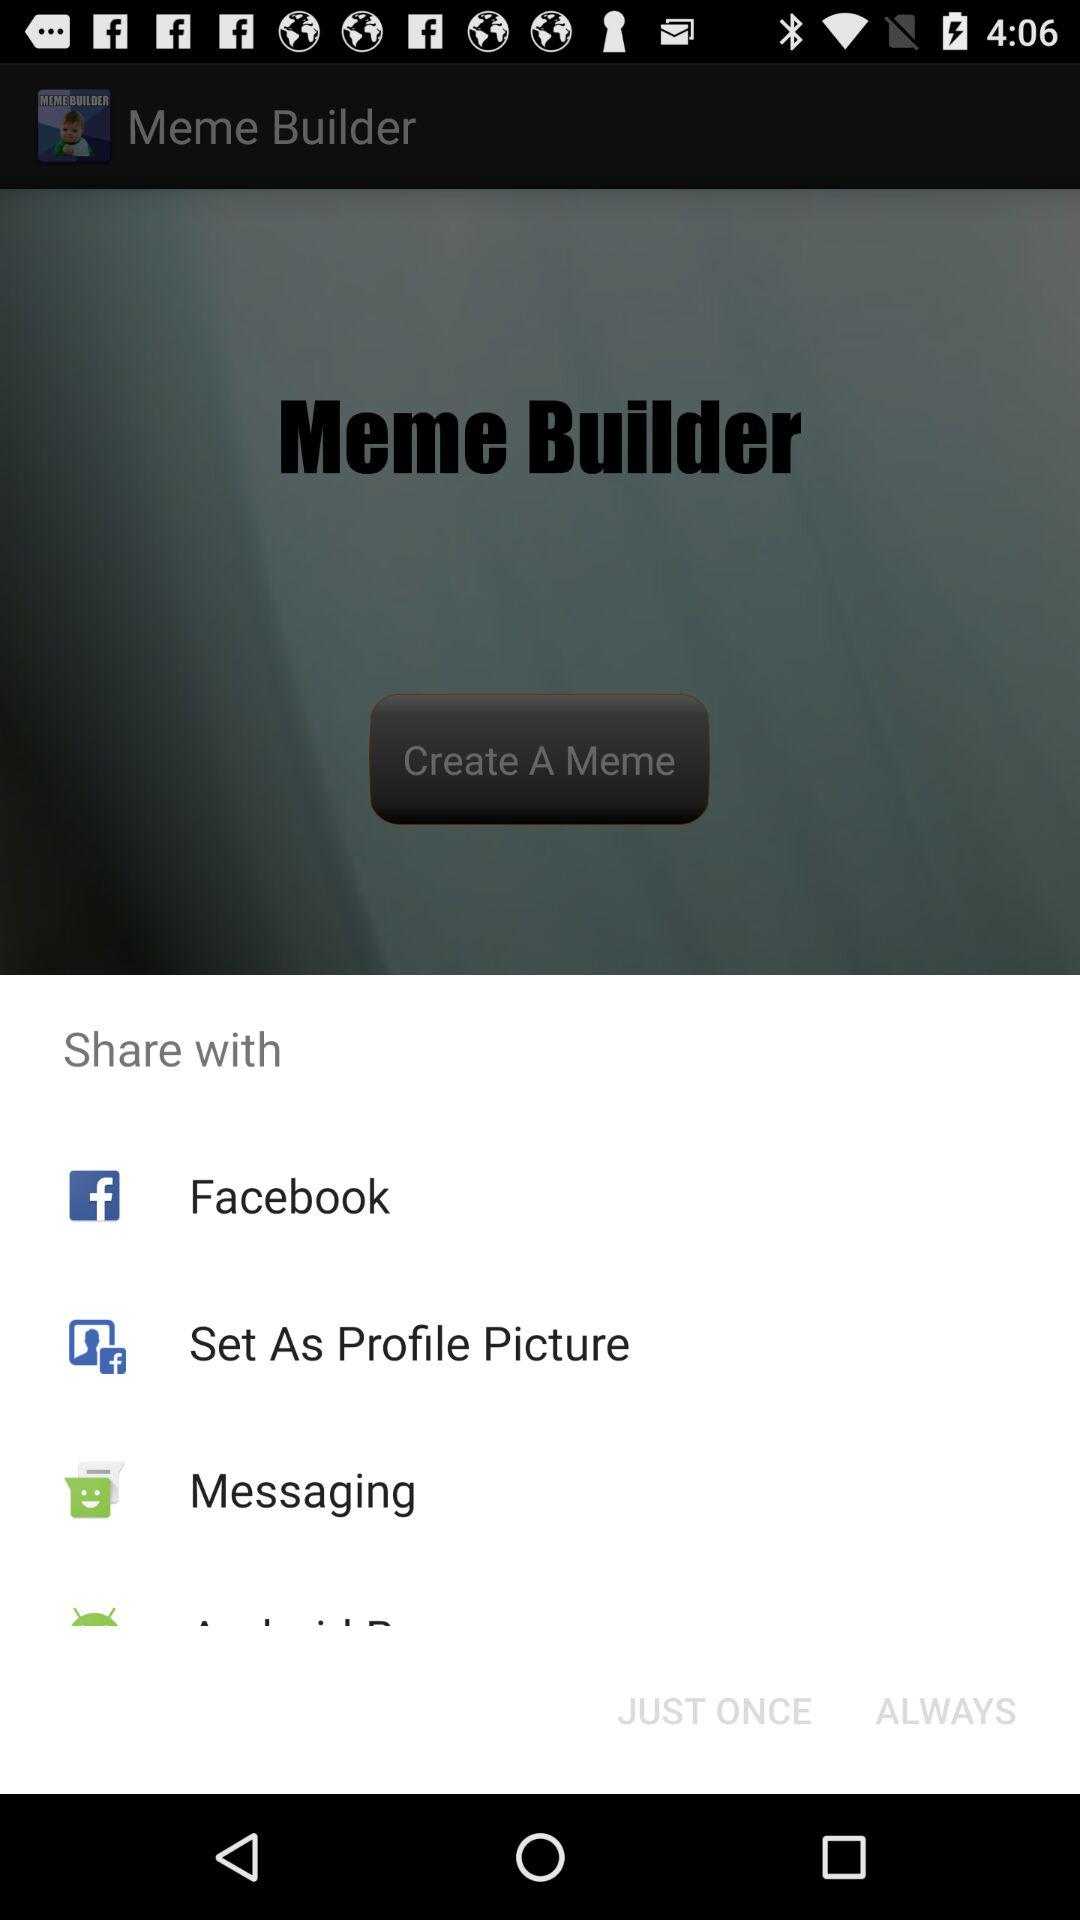Who developed the application "Meme Builder"?
When the provided information is insufficient, respond with <no answer>. <no answer> 